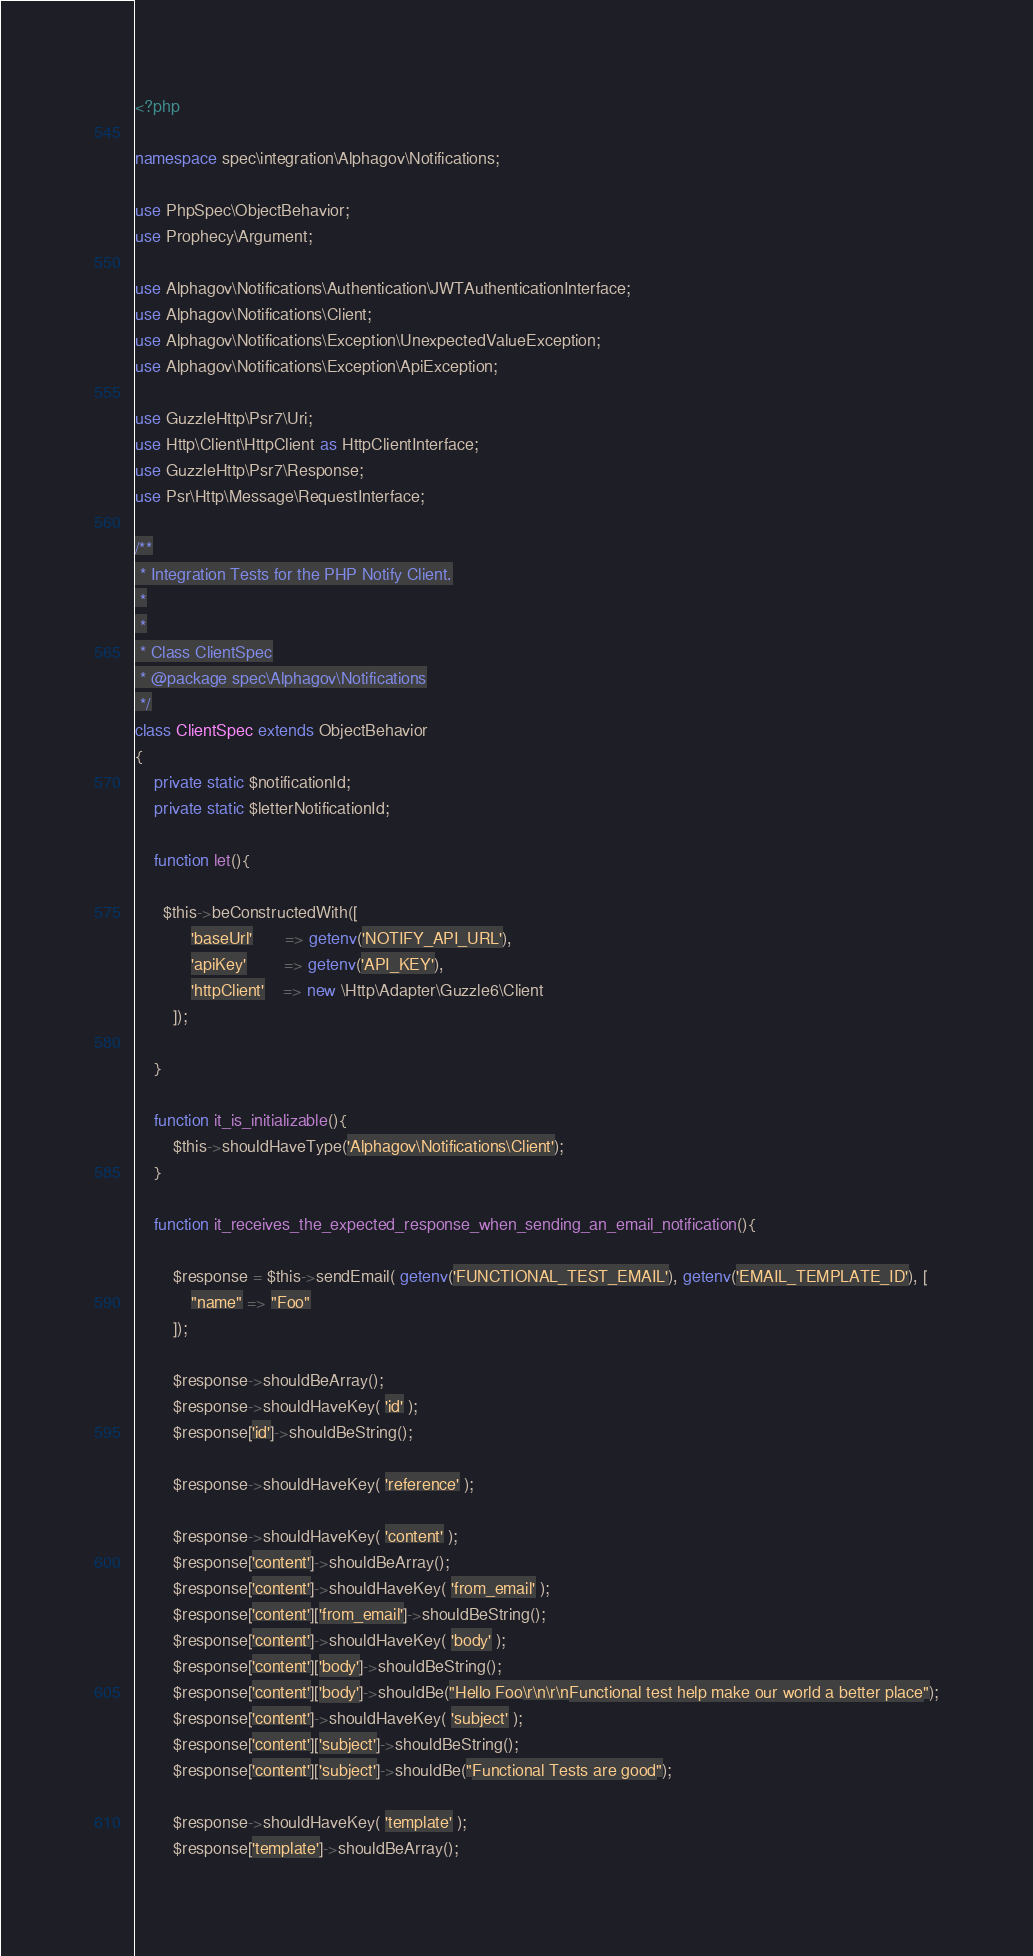Convert code to text. <code><loc_0><loc_0><loc_500><loc_500><_PHP_><?php

namespace spec\integration\Alphagov\Notifications;

use PhpSpec\ObjectBehavior;
use Prophecy\Argument;

use Alphagov\Notifications\Authentication\JWTAuthenticationInterface;
use Alphagov\Notifications\Client;
use Alphagov\Notifications\Exception\UnexpectedValueException;
use Alphagov\Notifications\Exception\ApiException;

use GuzzleHttp\Psr7\Uri;
use Http\Client\HttpClient as HttpClientInterface;
use GuzzleHttp\Psr7\Response;
use Psr\Http\Message\RequestInterface;

/**
 * Integration Tests for the PHP Notify Client.
 *
 *
 * Class ClientSpec
 * @package spec\Alphagov\Notifications
 */
class ClientSpec extends ObjectBehavior
{
    private static $notificationId;
    private static $letterNotificationId;

    function let(){

      $this->beConstructedWith([
            'baseUrl'       => getenv('NOTIFY_API_URL'),
            'apiKey'        => getenv('API_KEY'),
            'httpClient'    => new \Http\Adapter\Guzzle6\Client
        ]);

    }

    function it_is_initializable(){
        $this->shouldHaveType('Alphagov\Notifications\Client');
    }

    function it_receives_the_expected_response_when_sending_an_email_notification(){

        $response = $this->sendEmail( getenv('FUNCTIONAL_TEST_EMAIL'), getenv('EMAIL_TEMPLATE_ID'), [
            "name" => "Foo"
        ]);

        $response->shouldBeArray();
        $response->shouldHaveKey( 'id' );
        $response['id']->shouldBeString();

        $response->shouldHaveKey( 'reference' );

        $response->shouldHaveKey( 'content' );
        $response['content']->shouldBeArray();
        $response['content']->shouldHaveKey( 'from_email' );
        $response['content']['from_email']->shouldBeString();
        $response['content']->shouldHaveKey( 'body' );
        $response['content']['body']->shouldBeString();
        $response['content']['body']->shouldBe("Hello Foo\r\n\r\nFunctional test help make our world a better place");
        $response['content']->shouldHaveKey( 'subject' );
        $response['content']['subject']->shouldBeString();
        $response['content']['subject']->shouldBe("Functional Tests are good");

        $response->shouldHaveKey( 'template' );
        $response['template']->shouldBeArray();</code> 